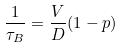Convert formula to latex. <formula><loc_0><loc_0><loc_500><loc_500>\frac { 1 } { \tau _ { B } } = \frac { V } { D } ( 1 - p )</formula> 